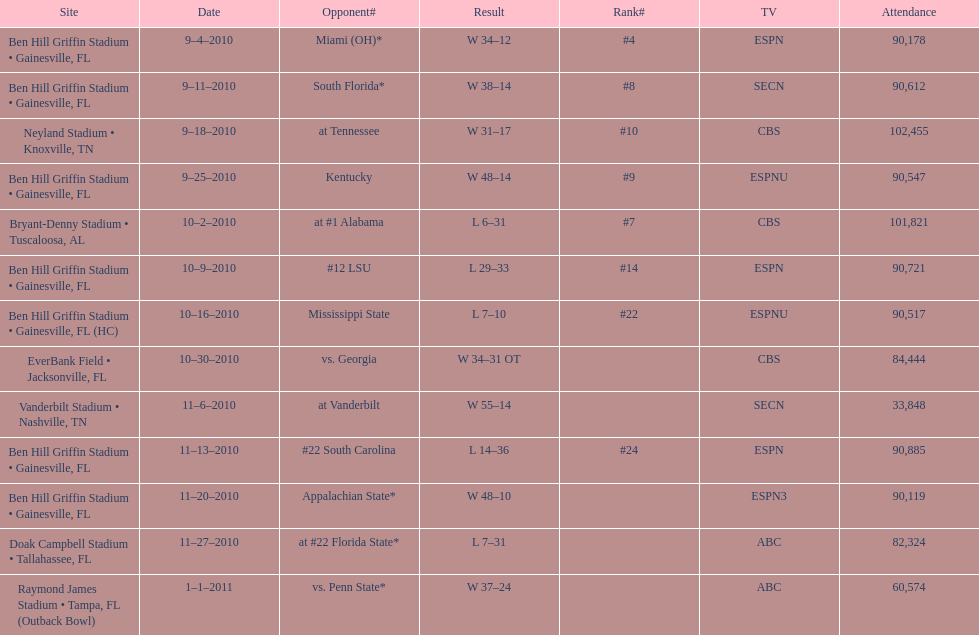What tv network showed the largest number of games during the 2010/2011 season? ESPN. 